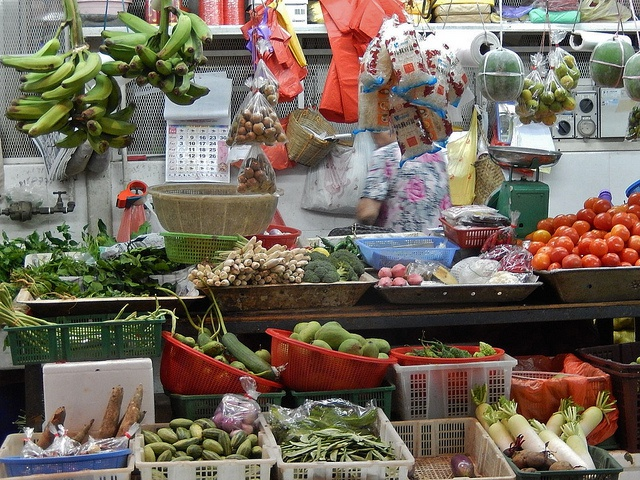Describe the objects in this image and their specific colors. I can see banana in lightgray, black, darkgreen, and olive tones, people in lightgray, darkgray, and gray tones, apple in lightgray, olive, gray, and black tones, and broccoli in lightgray, gray, darkgreen, and black tones in this image. 